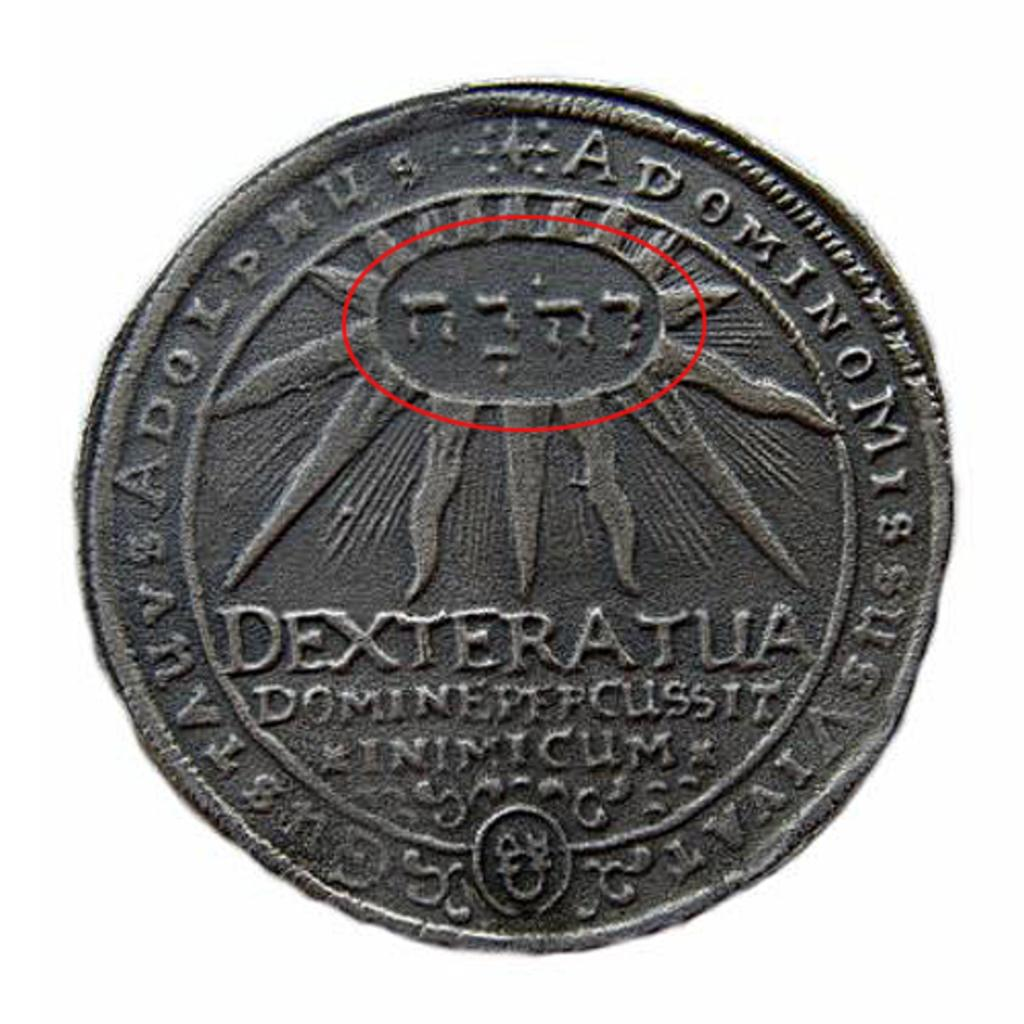<image>
Provide a brief description of the given image. Hebrew letters are engraved on a coin that also has DEXTERATUA engraved on the middle of the coin. . 